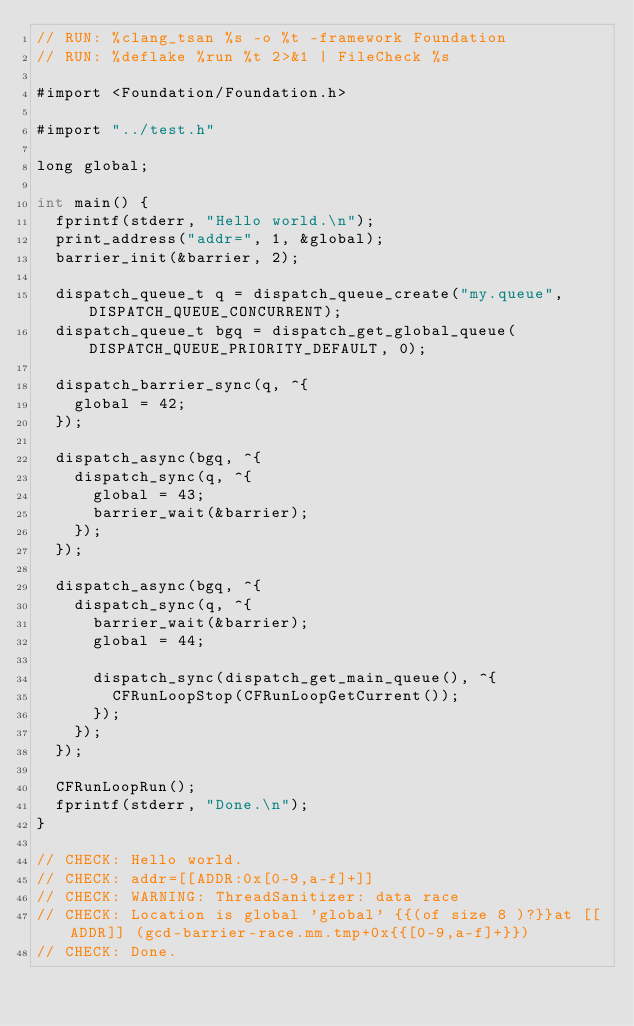Convert code to text. <code><loc_0><loc_0><loc_500><loc_500><_ObjectiveC_>// RUN: %clang_tsan %s -o %t -framework Foundation
// RUN: %deflake %run %t 2>&1 | FileCheck %s

#import <Foundation/Foundation.h>

#import "../test.h"

long global;

int main() {
  fprintf(stderr, "Hello world.\n");
  print_address("addr=", 1, &global);
  barrier_init(&barrier, 2);

  dispatch_queue_t q = dispatch_queue_create("my.queue", DISPATCH_QUEUE_CONCURRENT);
  dispatch_queue_t bgq = dispatch_get_global_queue(DISPATCH_QUEUE_PRIORITY_DEFAULT, 0);

  dispatch_barrier_sync(q, ^{
    global = 42;
  });

  dispatch_async(bgq, ^{
    dispatch_sync(q, ^{
      global = 43;
      barrier_wait(&barrier);
    });
  });

  dispatch_async(bgq, ^{
    dispatch_sync(q, ^{
      barrier_wait(&barrier);
      global = 44;

      dispatch_sync(dispatch_get_main_queue(), ^{
        CFRunLoopStop(CFRunLoopGetCurrent());
      });
    });
  });

  CFRunLoopRun();
  fprintf(stderr, "Done.\n");
}

// CHECK: Hello world.
// CHECK: addr=[[ADDR:0x[0-9,a-f]+]]
// CHECK: WARNING: ThreadSanitizer: data race
// CHECK: Location is global 'global' {{(of size 8 )?}}at [[ADDR]] (gcd-barrier-race.mm.tmp+0x{{[0-9,a-f]+}})
// CHECK: Done.
</code> 